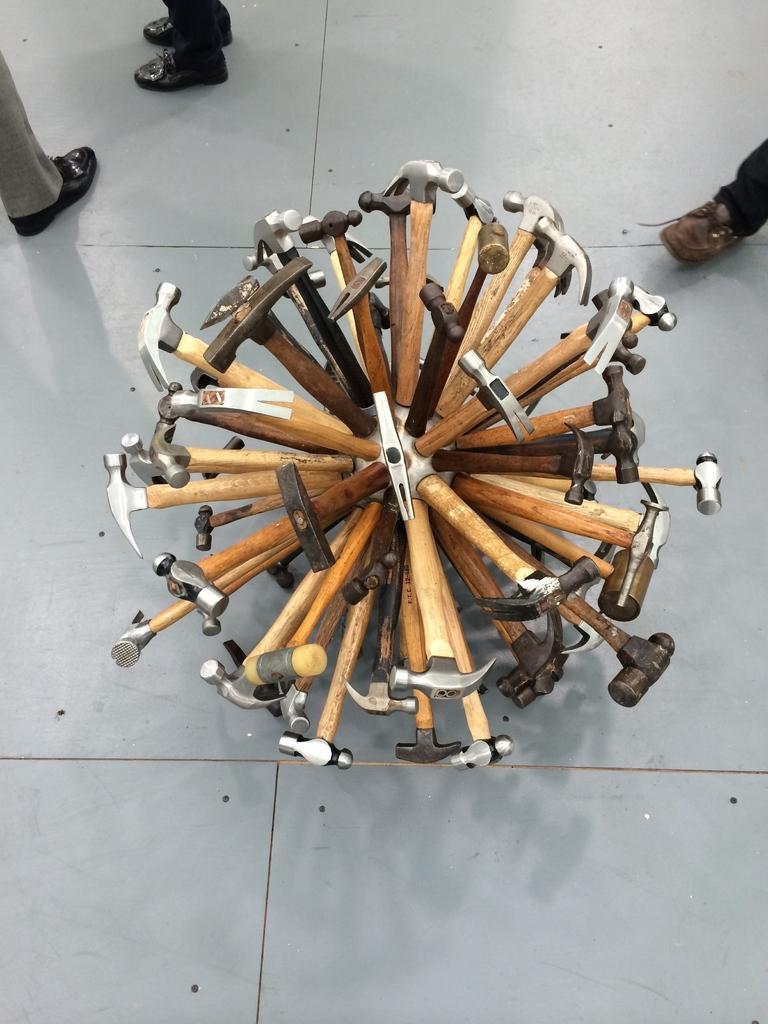Describe this image in one or two sentences. We can see people legs with footwear on the floor and we can see hammers and tools. 